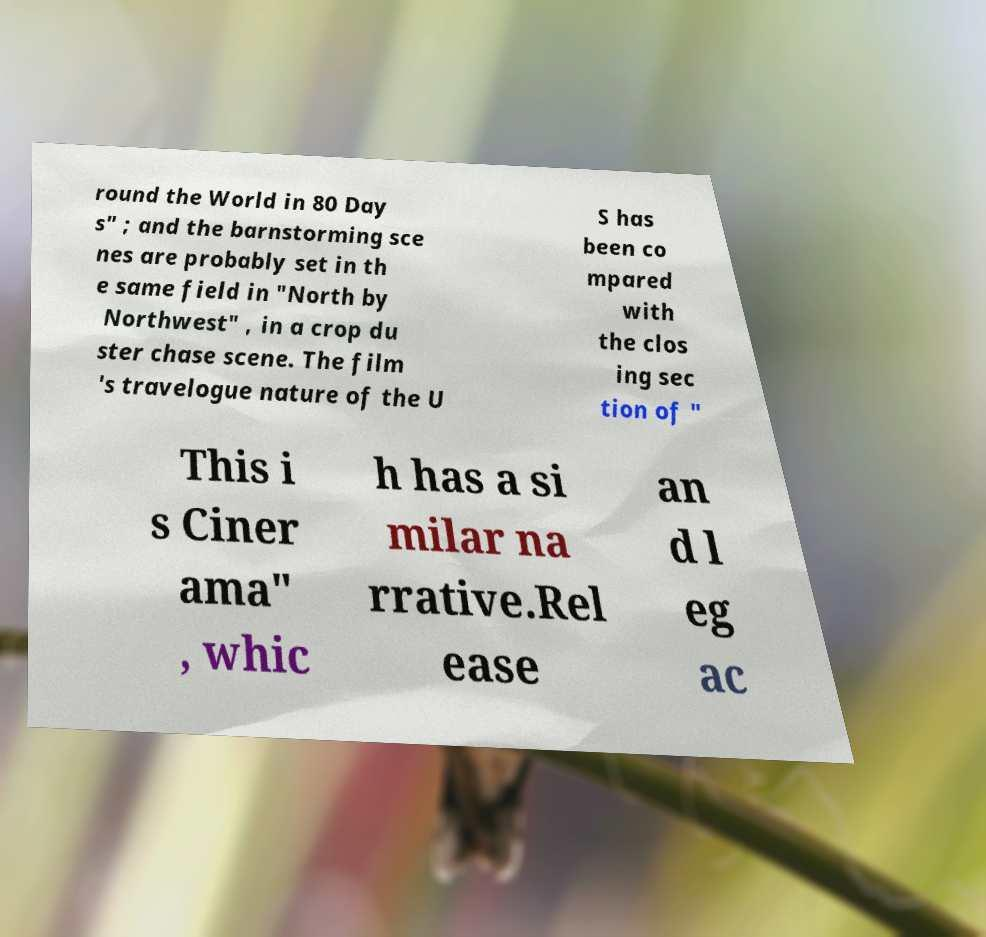What messages or text are displayed in this image? I need them in a readable, typed format. round the World in 80 Day s" ; and the barnstorming sce nes are probably set in th e same field in "North by Northwest" , in a crop du ster chase scene. The film 's travelogue nature of the U S has been co mpared with the clos ing sec tion of " This i s Ciner ama" , whic h has a si milar na rrative.Rel ease an d l eg ac 